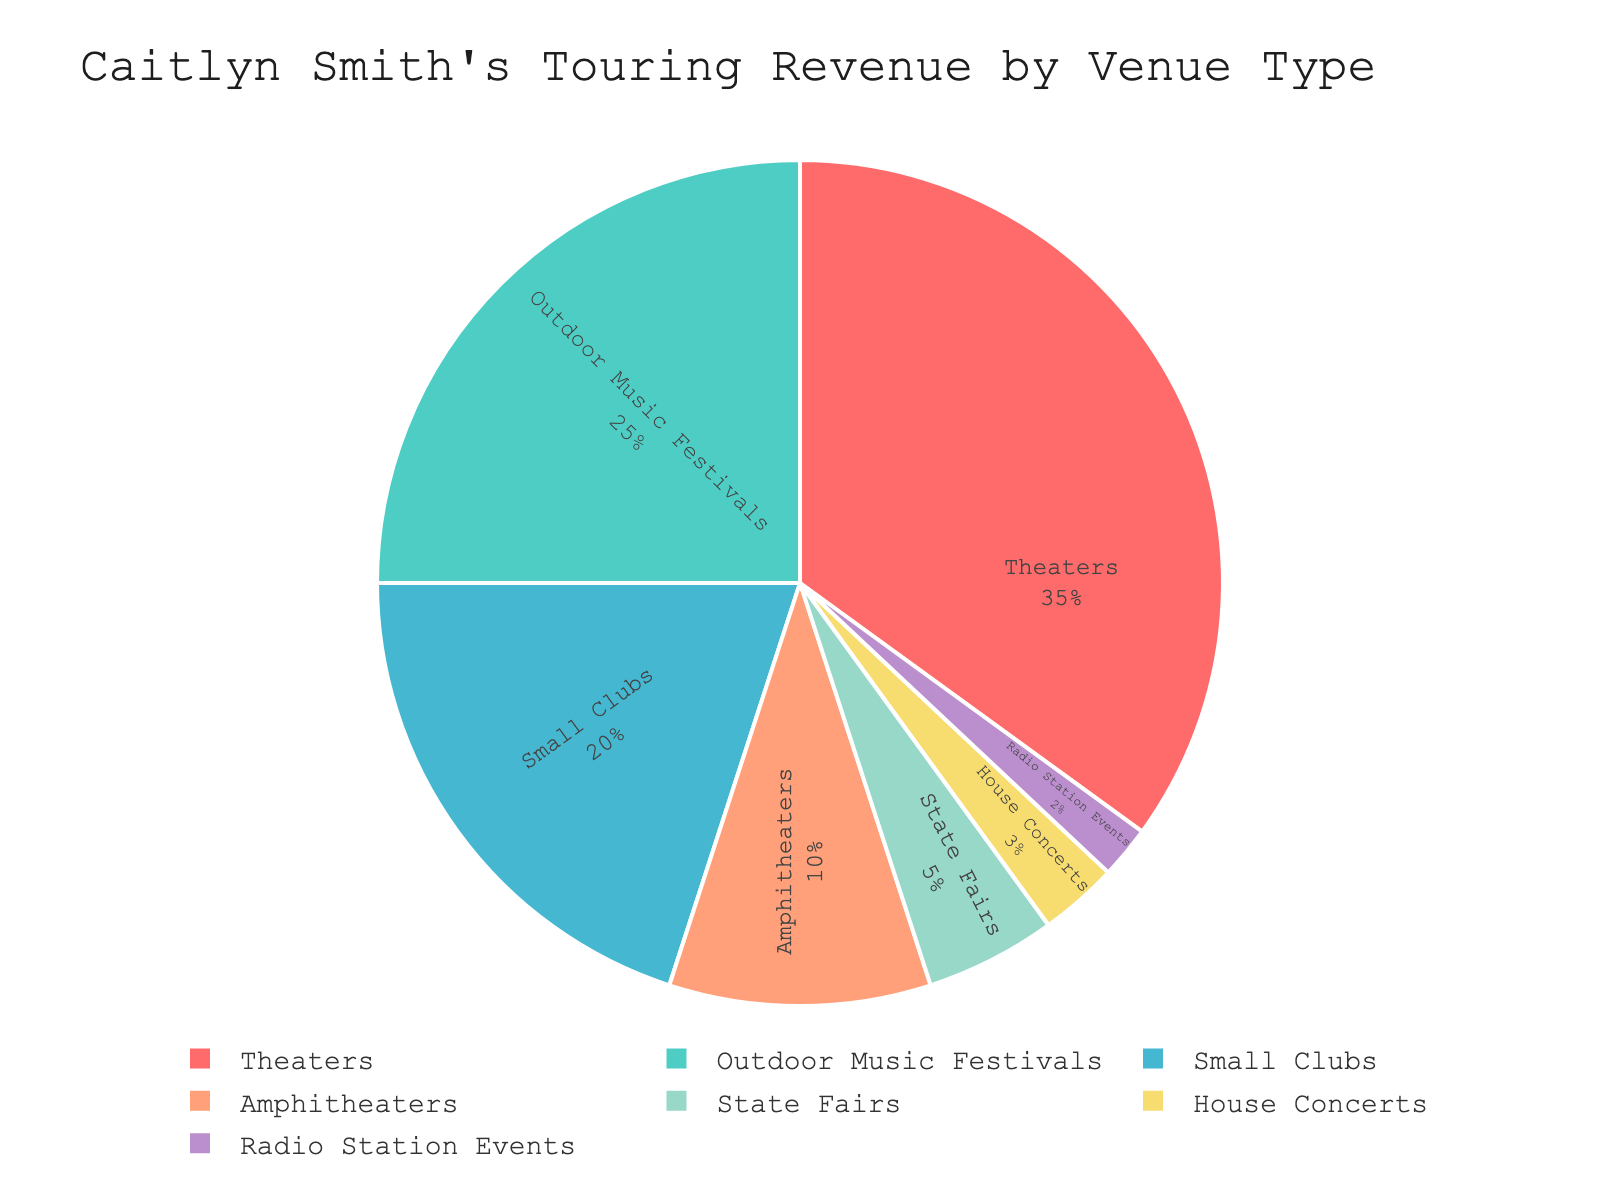What's the percentage of revenue generated from theaters and amphitheaters combined? The percentage of revenue from theaters is 35% and from amphitheaters is 10%. Summing these values: 35 + 10 = 45.
Answer: 45% Which venue type contributes the smallest percentage to Caitlyn Smith's touring revenue? From the pie chart, Radio Station Events contribute the smallest percentage, which is 2%.
Answer: Radio Station Events How does the revenue percentage from Small Clubs compare to that from Outdoor Music Festivals? The percentage of revenue from Small Clubs is 20%, while from Outdoor Music Festivals it is 25%. Since 25% > 20%, Outdoor Music Festivals contribute more.
Answer: Outdoor Music Festivals contribute more What is the total percentage of revenue generated from State Fairs, House Concerts, and Radio Station Events? The percentages are: State Fairs (5%), House Concerts (3%), and Radio Station Events (2%). Summing these values: 5 + 3 + 2 = 10.
Answer: 10% If you combine the revenue from Outdoor Music Festivals and Small Clubs, does it surpass the revenue from Theaters? Revenue from Outdoor Music Festivals is 25% and from Small Clubs it is 20%. Combined, 25 + 20 = 45%. The revenue from Theaters is 35%. Since 45% > 35%, it surpasses.
Answer: Yes Identify the venue type with the second-largest revenue percentage and state its corresponding percentage. Theaters have the largest percentage (35%). The second-largest percentage is from Outdoor Music Festivals, with 25%.
Answer: Outdoor Music Festivals, 25% What’s the difference in revenue percentage between Theaters and Small Clubs? The revenue percentage from Theaters is 35% and from Small Clubs is 20%. The difference is 35 - 20 = 15.
Answer: 15% Describe the pie chart color associated with Amphitheaters. The slice representing Amphitheaters is colored blue.
Answer: Blue What fraction of the total revenue is generated from venue types other than Theaters? The percentage for venues other than Theaters is: Outdoor Music Festivals (25%), Small Clubs (20%), Amphitheaters (10%), State Fairs (5%), House Concerts (3%), and Radio Station Events (2%). Summing these gives: 25 + 20 + 10 + 5 + 3 + 2 = 65%. Thus, 65/100 = 0.65.
Answer: 0.65 Is the revenue percentage from House Concerts greater than or equal to the sum of the percentages from State Fairs and Radio Station Events? The revenue from House Concerts is 3%. The sum of percentages from State Fairs (5%) and Radio Station Events (2%) is: 5 + 2 = 7%. Since 3% < 7%, it is not greater or equal.
Answer: No 